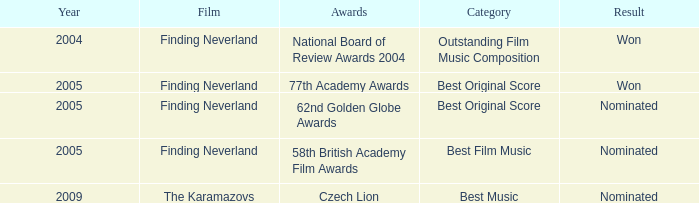Which awards happened more recently than 2005? Czech Lion. 